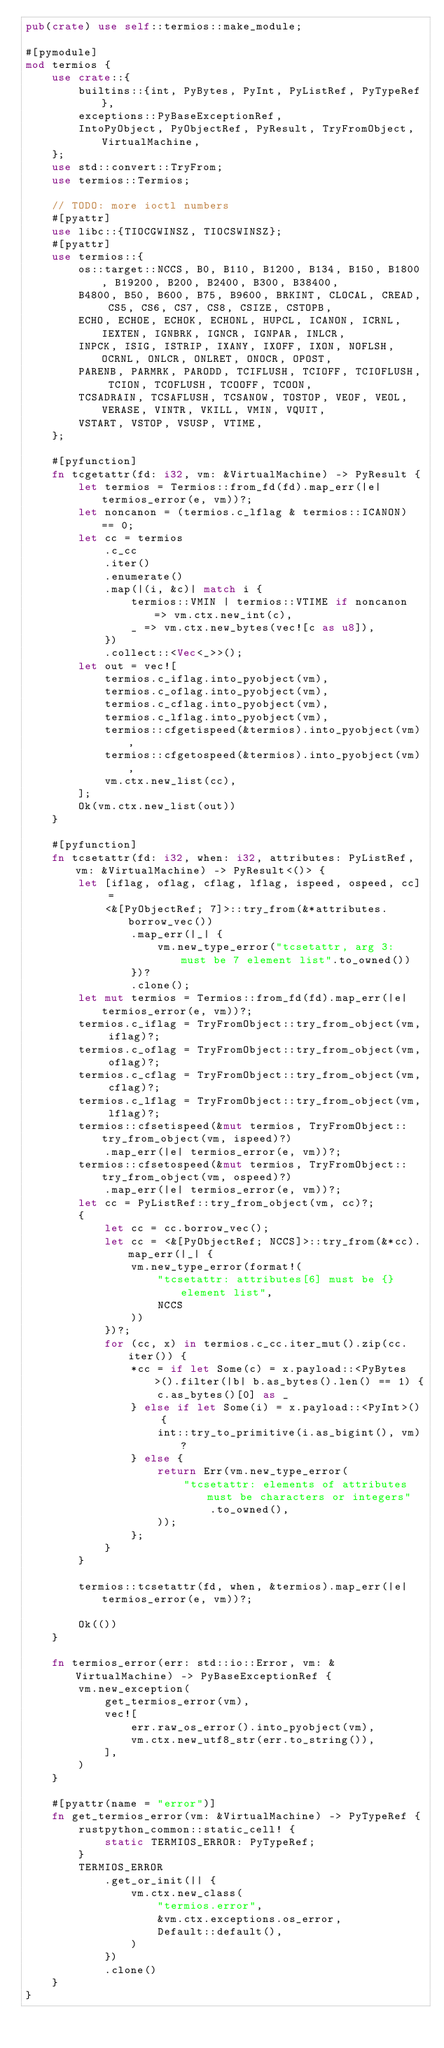Convert code to text. <code><loc_0><loc_0><loc_500><loc_500><_Rust_>pub(crate) use self::termios::make_module;

#[pymodule]
mod termios {
    use crate::{
        builtins::{int, PyBytes, PyInt, PyListRef, PyTypeRef},
        exceptions::PyBaseExceptionRef,
        IntoPyObject, PyObjectRef, PyResult, TryFromObject, VirtualMachine,
    };
    use std::convert::TryFrom;
    use termios::Termios;

    // TODO: more ioctl numbers
    #[pyattr]
    use libc::{TIOCGWINSZ, TIOCSWINSZ};
    #[pyattr]
    use termios::{
        os::target::NCCS, B0, B110, B1200, B134, B150, B1800, B19200, B200, B2400, B300, B38400,
        B4800, B50, B600, B75, B9600, BRKINT, CLOCAL, CREAD, CS5, CS6, CS7, CS8, CSIZE, CSTOPB,
        ECHO, ECHOE, ECHOK, ECHONL, HUPCL, ICANON, ICRNL, IEXTEN, IGNBRK, IGNCR, IGNPAR, INLCR,
        INPCK, ISIG, ISTRIP, IXANY, IXOFF, IXON, NOFLSH, OCRNL, ONLCR, ONLRET, ONOCR, OPOST,
        PARENB, PARMRK, PARODD, TCIFLUSH, TCIOFF, TCIOFLUSH, TCION, TCOFLUSH, TCOOFF, TCOON,
        TCSADRAIN, TCSAFLUSH, TCSANOW, TOSTOP, VEOF, VEOL, VERASE, VINTR, VKILL, VMIN, VQUIT,
        VSTART, VSTOP, VSUSP, VTIME,
    };

    #[pyfunction]
    fn tcgetattr(fd: i32, vm: &VirtualMachine) -> PyResult {
        let termios = Termios::from_fd(fd).map_err(|e| termios_error(e, vm))?;
        let noncanon = (termios.c_lflag & termios::ICANON) == 0;
        let cc = termios
            .c_cc
            .iter()
            .enumerate()
            .map(|(i, &c)| match i {
                termios::VMIN | termios::VTIME if noncanon => vm.ctx.new_int(c),
                _ => vm.ctx.new_bytes(vec![c as u8]),
            })
            .collect::<Vec<_>>();
        let out = vec![
            termios.c_iflag.into_pyobject(vm),
            termios.c_oflag.into_pyobject(vm),
            termios.c_cflag.into_pyobject(vm),
            termios.c_lflag.into_pyobject(vm),
            termios::cfgetispeed(&termios).into_pyobject(vm),
            termios::cfgetospeed(&termios).into_pyobject(vm),
            vm.ctx.new_list(cc),
        ];
        Ok(vm.ctx.new_list(out))
    }

    #[pyfunction]
    fn tcsetattr(fd: i32, when: i32, attributes: PyListRef, vm: &VirtualMachine) -> PyResult<()> {
        let [iflag, oflag, cflag, lflag, ispeed, ospeed, cc] =
            <&[PyObjectRef; 7]>::try_from(&*attributes.borrow_vec())
                .map_err(|_| {
                    vm.new_type_error("tcsetattr, arg 3: must be 7 element list".to_owned())
                })?
                .clone();
        let mut termios = Termios::from_fd(fd).map_err(|e| termios_error(e, vm))?;
        termios.c_iflag = TryFromObject::try_from_object(vm, iflag)?;
        termios.c_oflag = TryFromObject::try_from_object(vm, oflag)?;
        termios.c_cflag = TryFromObject::try_from_object(vm, cflag)?;
        termios.c_lflag = TryFromObject::try_from_object(vm, lflag)?;
        termios::cfsetispeed(&mut termios, TryFromObject::try_from_object(vm, ispeed)?)
            .map_err(|e| termios_error(e, vm))?;
        termios::cfsetospeed(&mut termios, TryFromObject::try_from_object(vm, ospeed)?)
            .map_err(|e| termios_error(e, vm))?;
        let cc = PyListRef::try_from_object(vm, cc)?;
        {
            let cc = cc.borrow_vec();
            let cc = <&[PyObjectRef; NCCS]>::try_from(&*cc).map_err(|_| {
                vm.new_type_error(format!(
                    "tcsetattr: attributes[6] must be {} element list",
                    NCCS
                ))
            })?;
            for (cc, x) in termios.c_cc.iter_mut().zip(cc.iter()) {
                *cc = if let Some(c) = x.payload::<PyBytes>().filter(|b| b.as_bytes().len() == 1) {
                    c.as_bytes()[0] as _
                } else if let Some(i) = x.payload::<PyInt>() {
                    int::try_to_primitive(i.as_bigint(), vm)?
                } else {
                    return Err(vm.new_type_error(
                        "tcsetattr: elements of attributes must be characters or integers"
                            .to_owned(),
                    ));
                };
            }
        }

        termios::tcsetattr(fd, when, &termios).map_err(|e| termios_error(e, vm))?;

        Ok(())
    }

    fn termios_error(err: std::io::Error, vm: &VirtualMachine) -> PyBaseExceptionRef {
        vm.new_exception(
            get_termios_error(vm),
            vec![
                err.raw_os_error().into_pyobject(vm),
                vm.ctx.new_utf8_str(err.to_string()),
            ],
        )
    }

    #[pyattr(name = "error")]
    fn get_termios_error(vm: &VirtualMachine) -> PyTypeRef {
        rustpython_common::static_cell! {
            static TERMIOS_ERROR: PyTypeRef;
        }
        TERMIOS_ERROR
            .get_or_init(|| {
                vm.ctx.new_class(
                    "termios.error",
                    &vm.ctx.exceptions.os_error,
                    Default::default(),
                )
            })
            .clone()
    }
}
</code> 